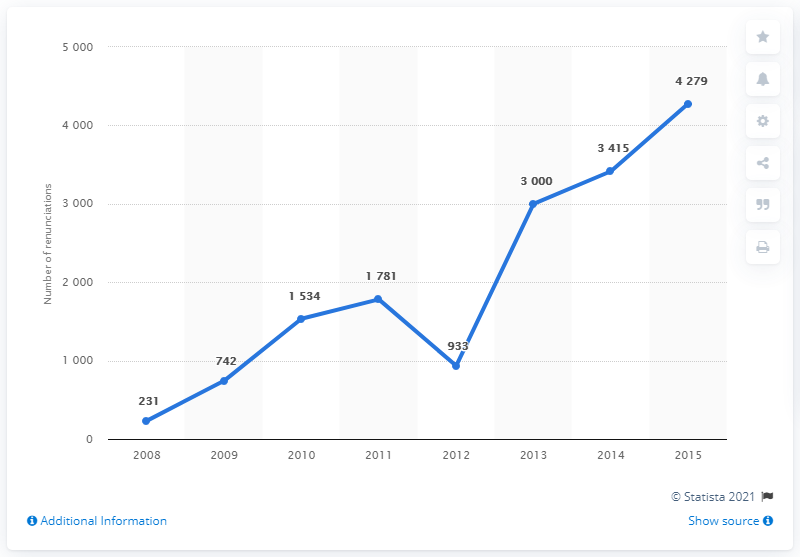Outline some significant characteristics in this image. The year with a drastic increase is 2013. The average of values above 2000 is approximately 3564.67. 